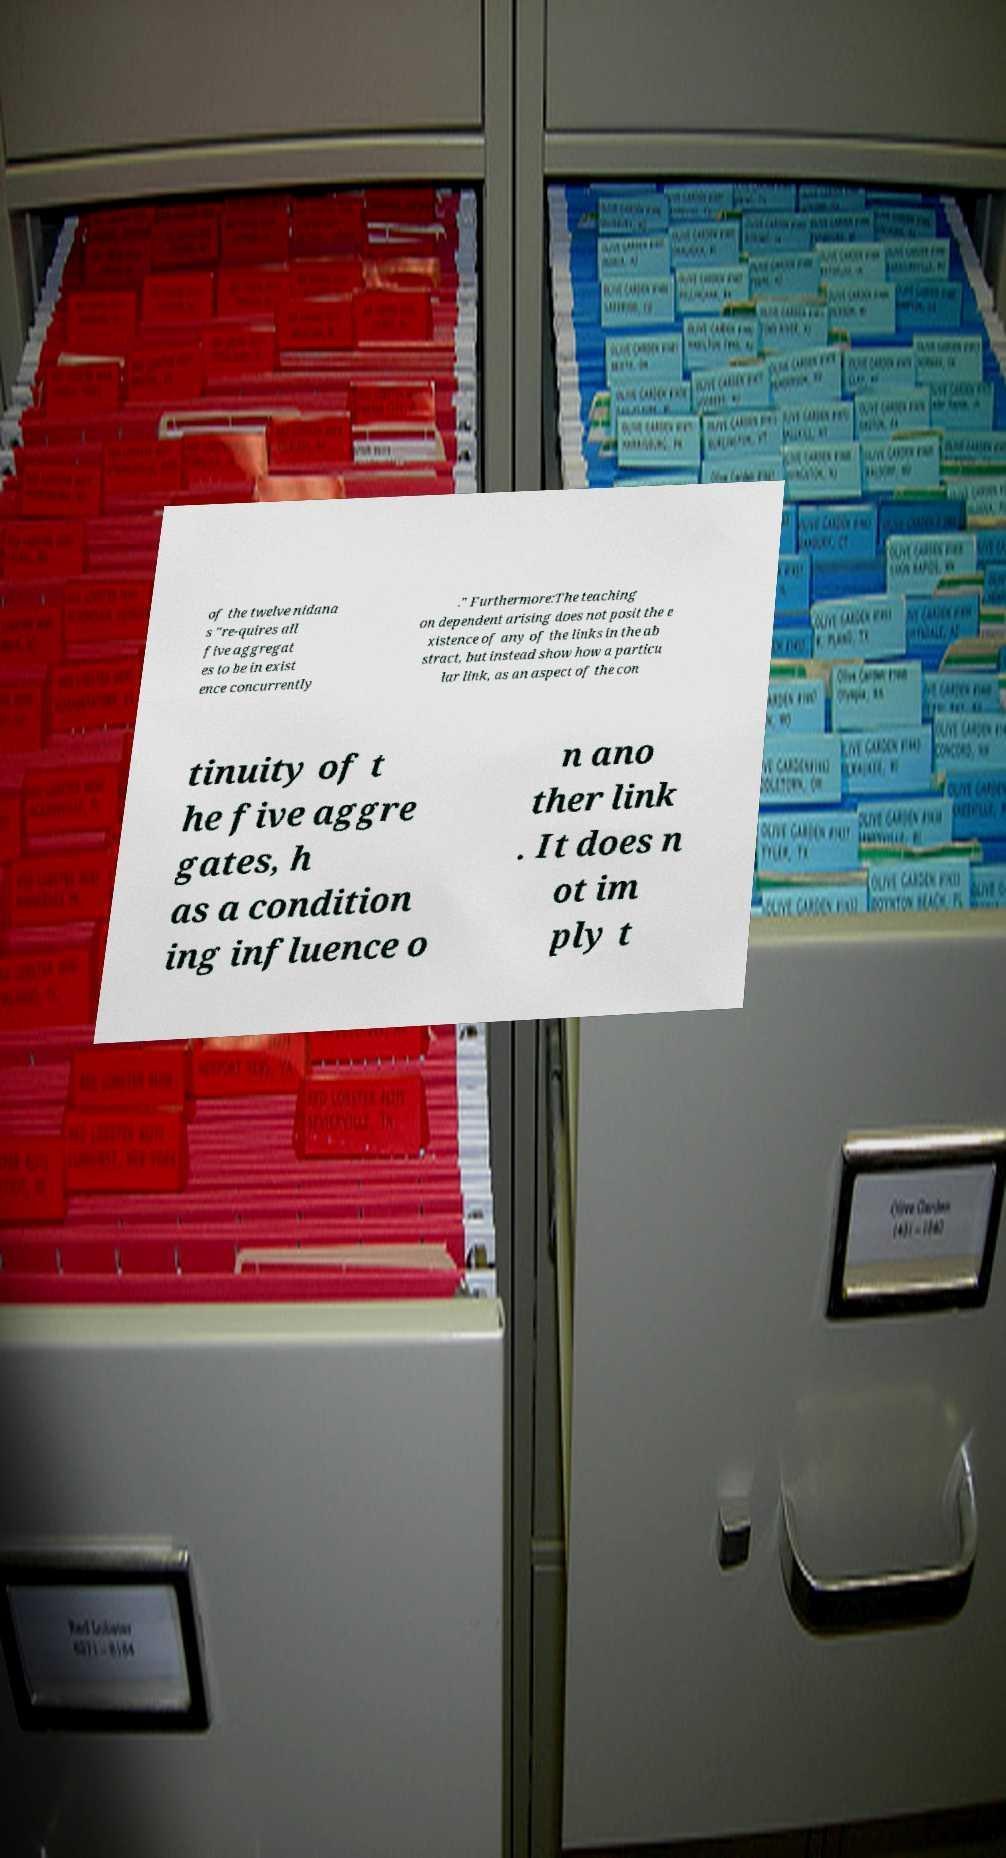Could you assist in decoding the text presented in this image and type it out clearly? of the twelve nidana s "re-quires all five aggregat es to be in exist ence concurrently ." Furthermore:The teaching on dependent arising does not posit the e xistence of any of the links in the ab stract, but instead show how a particu lar link, as an aspect of the con tinuity of t he five aggre gates, h as a condition ing influence o n ano ther link . It does n ot im ply t 